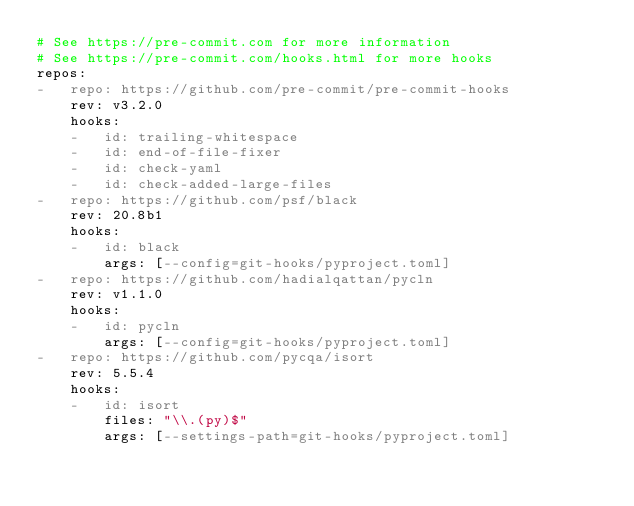<code> <loc_0><loc_0><loc_500><loc_500><_YAML_># See https://pre-commit.com for more information
# See https://pre-commit.com/hooks.html for more hooks
repos:
-   repo: https://github.com/pre-commit/pre-commit-hooks
    rev: v3.2.0
    hooks:
    -   id: trailing-whitespace
    -   id: end-of-file-fixer
    -   id: check-yaml
    -   id: check-added-large-files
-   repo: https://github.com/psf/black
    rev: 20.8b1
    hooks:
    -   id: black
        args: [--config=git-hooks/pyproject.toml]
-   repo: https://github.com/hadialqattan/pycln
    rev: v1.1.0
    hooks:
    -   id: pycln
        args: [--config=git-hooks/pyproject.toml]
-   repo: https://github.com/pycqa/isort
    rev: 5.5.4
    hooks:
    -   id: isort
        files: "\\.(py)$"
        args: [--settings-path=git-hooks/pyproject.toml]
</code> 